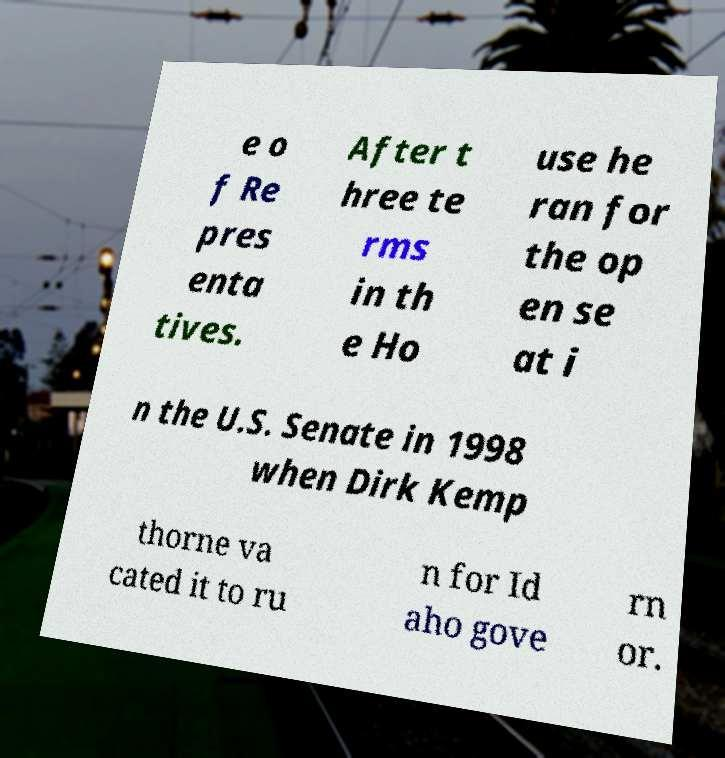For documentation purposes, I need the text within this image transcribed. Could you provide that? e o f Re pres enta tives. After t hree te rms in th e Ho use he ran for the op en se at i n the U.S. Senate in 1998 when Dirk Kemp thorne va cated it to ru n for Id aho gove rn or. 